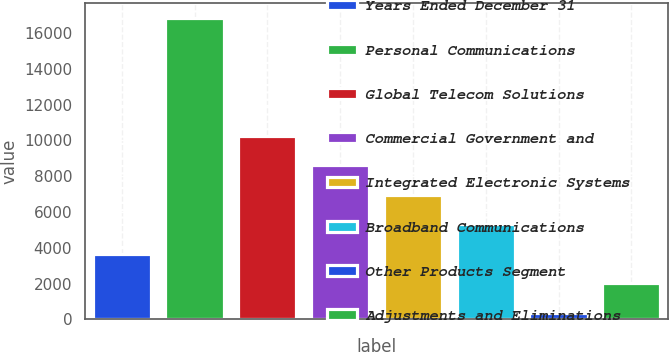Convert chart to OTSL. <chart><loc_0><loc_0><loc_500><loc_500><bar_chart><fcel>Years Ended December 31<fcel>Personal Communications<fcel>Global Telecom Solutions<fcel>Commercial Government and<fcel>Integrated Electronic Systems<fcel>Broadband Communications<fcel>Other Products Segment<fcel>Adjustments and Eliminations<nl><fcel>3674.2<fcel>16823<fcel>10248.6<fcel>8605<fcel>6961.4<fcel>5317.8<fcel>387<fcel>2030.6<nl></chart> 